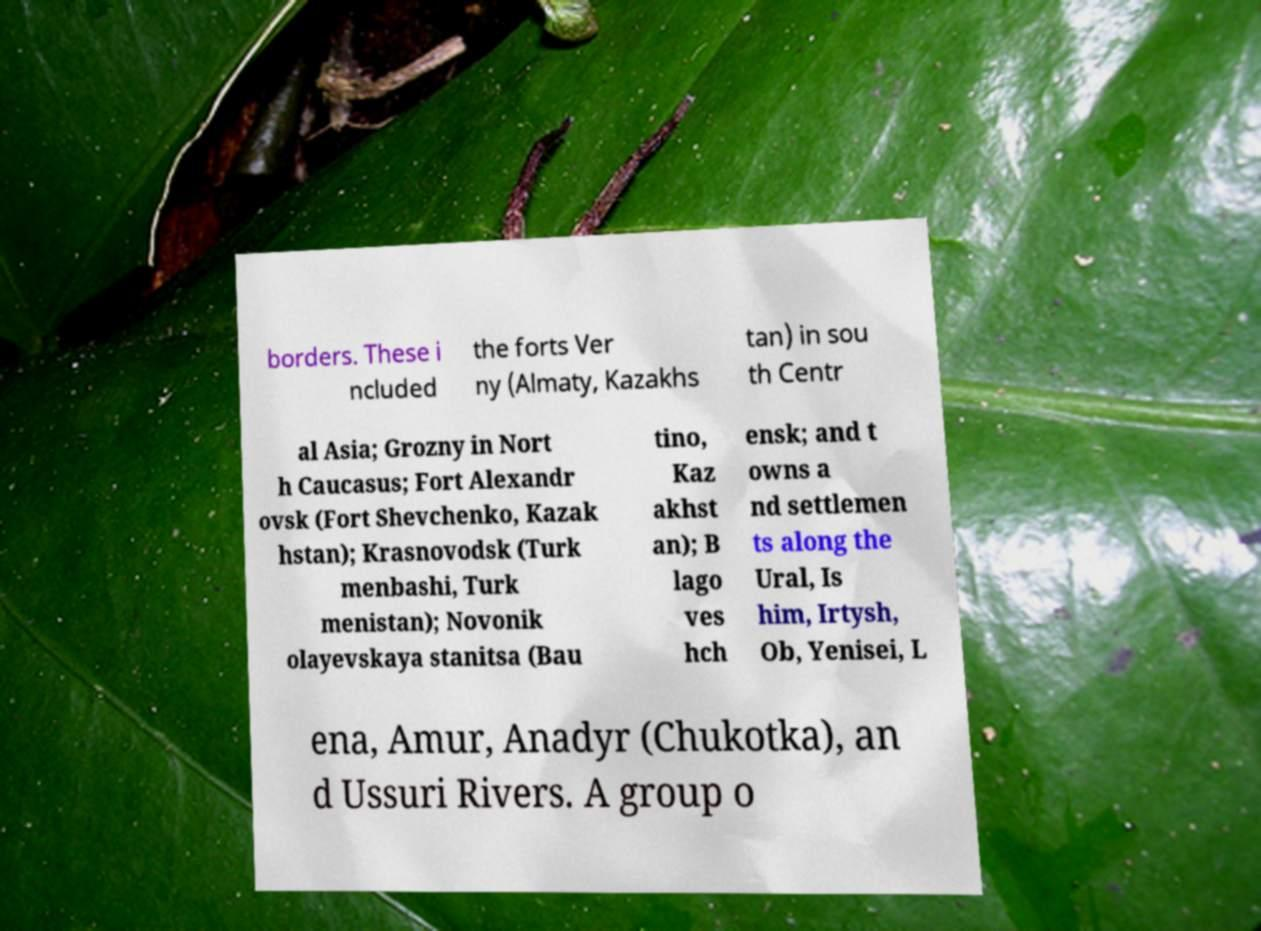What messages or text are displayed in this image? I need them in a readable, typed format. borders. These i ncluded the forts Ver ny (Almaty, Kazakhs tan) in sou th Centr al Asia; Grozny in Nort h Caucasus; Fort Alexandr ovsk (Fort Shevchenko, Kazak hstan); Krasnovodsk (Turk menbashi, Turk menistan); Novonik olayevskaya stanitsa (Bau tino, Kaz akhst an); B lago ves hch ensk; and t owns a nd settlemen ts along the Ural, Is him, Irtysh, Ob, Yenisei, L ena, Amur, Anadyr (Chukotka), an d Ussuri Rivers. A group o 